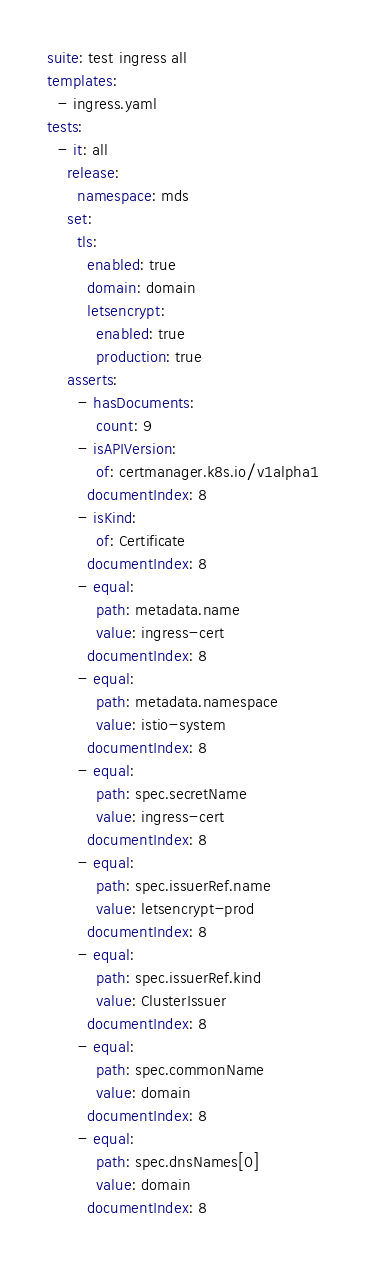Convert code to text. <code><loc_0><loc_0><loc_500><loc_500><_YAML_>suite: test ingress all
templates:
  - ingress.yaml
tests:
  - it: all
    release:
      namespace: mds
    set:
      tls:
        enabled: true
        domain: domain
        letsencrypt:
          enabled: true
          production: true
    asserts:
      - hasDocuments:
          count: 9
      - isAPIVersion:
          of: certmanager.k8s.io/v1alpha1
        documentIndex: 8
      - isKind:
          of: Certificate
        documentIndex: 8
      - equal:
          path: metadata.name
          value: ingress-cert
        documentIndex: 8
      - equal:
          path: metadata.namespace
          value: istio-system
        documentIndex: 8
      - equal:
          path: spec.secretName
          value: ingress-cert
        documentIndex: 8
      - equal:
          path: spec.issuerRef.name
          value: letsencrypt-prod
        documentIndex: 8
      - equal:
          path: spec.issuerRef.kind
          value: ClusterIssuer
        documentIndex: 8
      - equal:
          path: spec.commonName
          value: domain
        documentIndex: 8
      - equal:
          path: spec.dnsNames[0]
          value: domain
        documentIndex: 8</code> 